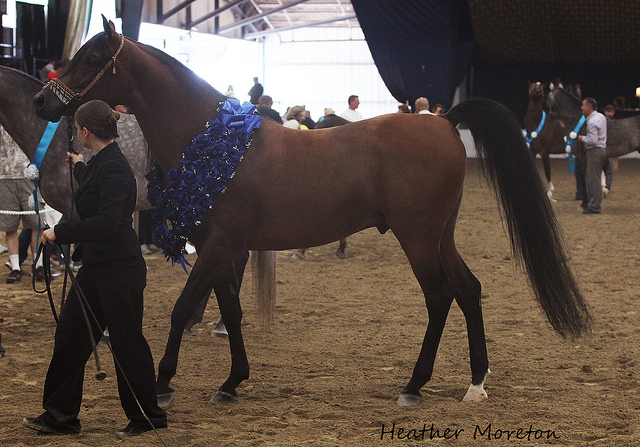Please transcribe the text information in this image. Heather Moreton 